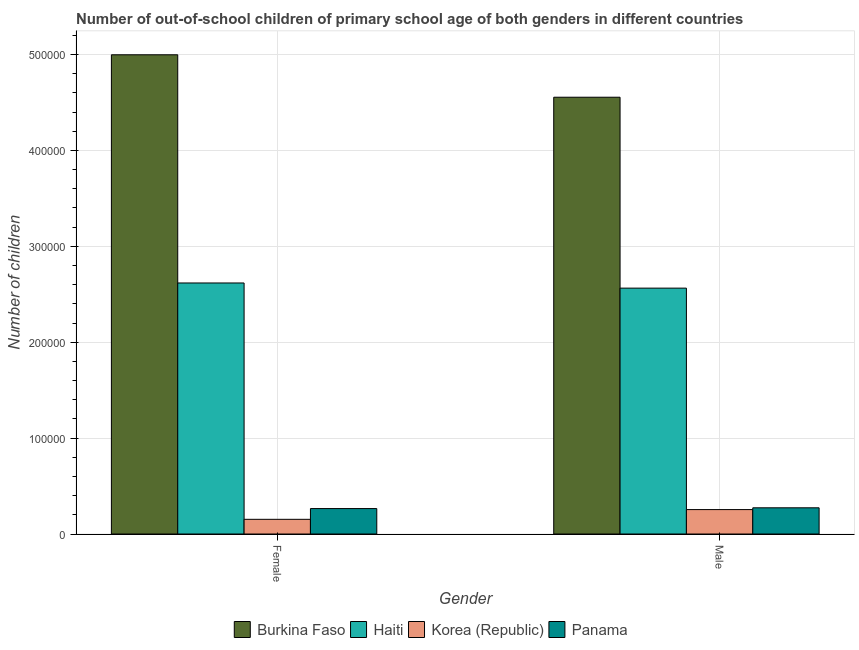How many different coloured bars are there?
Ensure brevity in your answer.  4. What is the number of female out-of-school students in Burkina Faso?
Provide a succinct answer. 5.00e+05. Across all countries, what is the maximum number of female out-of-school students?
Offer a terse response. 5.00e+05. Across all countries, what is the minimum number of female out-of-school students?
Keep it short and to the point. 1.53e+04. In which country was the number of male out-of-school students maximum?
Keep it short and to the point. Burkina Faso. In which country was the number of female out-of-school students minimum?
Give a very brief answer. Korea (Republic). What is the total number of female out-of-school students in the graph?
Your answer should be very brief. 8.03e+05. What is the difference between the number of male out-of-school students in Haiti and that in Korea (Republic)?
Your answer should be very brief. 2.31e+05. What is the difference between the number of male out-of-school students in Burkina Faso and the number of female out-of-school students in Panama?
Provide a short and direct response. 4.29e+05. What is the average number of male out-of-school students per country?
Your answer should be compact. 1.91e+05. What is the difference between the number of male out-of-school students and number of female out-of-school students in Panama?
Give a very brief answer. 795. In how many countries, is the number of female out-of-school students greater than 360000 ?
Provide a short and direct response. 1. What is the ratio of the number of male out-of-school students in Haiti to that in Korea (Republic)?
Your response must be concise. 10.07. Is the number of female out-of-school students in Panama less than that in Korea (Republic)?
Your answer should be very brief. No. What does the 2nd bar from the left in Male represents?
Keep it short and to the point. Haiti. What does the 1st bar from the right in Male represents?
Ensure brevity in your answer.  Panama. How many bars are there?
Your response must be concise. 8. Are all the bars in the graph horizontal?
Ensure brevity in your answer.  No. What is the difference between two consecutive major ticks on the Y-axis?
Provide a short and direct response. 1.00e+05. How many legend labels are there?
Make the answer very short. 4. How are the legend labels stacked?
Make the answer very short. Horizontal. What is the title of the graph?
Your answer should be very brief. Number of out-of-school children of primary school age of both genders in different countries. Does "West Bank and Gaza" appear as one of the legend labels in the graph?
Offer a terse response. No. What is the label or title of the Y-axis?
Provide a succinct answer. Number of children. What is the Number of children of Burkina Faso in Female?
Your response must be concise. 5.00e+05. What is the Number of children in Haiti in Female?
Give a very brief answer. 2.62e+05. What is the Number of children in Korea (Republic) in Female?
Your answer should be compact. 1.53e+04. What is the Number of children in Panama in Female?
Offer a very short reply. 2.65e+04. What is the Number of children of Burkina Faso in Male?
Keep it short and to the point. 4.55e+05. What is the Number of children in Haiti in Male?
Keep it short and to the point. 2.56e+05. What is the Number of children of Korea (Republic) in Male?
Your answer should be very brief. 2.55e+04. What is the Number of children of Panama in Male?
Give a very brief answer. 2.73e+04. Across all Gender, what is the maximum Number of children of Burkina Faso?
Your response must be concise. 5.00e+05. Across all Gender, what is the maximum Number of children of Haiti?
Provide a succinct answer. 2.62e+05. Across all Gender, what is the maximum Number of children in Korea (Republic)?
Provide a succinct answer. 2.55e+04. Across all Gender, what is the maximum Number of children in Panama?
Make the answer very short. 2.73e+04. Across all Gender, what is the minimum Number of children in Burkina Faso?
Provide a succinct answer. 4.55e+05. Across all Gender, what is the minimum Number of children of Haiti?
Provide a short and direct response. 2.56e+05. Across all Gender, what is the minimum Number of children in Korea (Republic)?
Keep it short and to the point. 1.53e+04. Across all Gender, what is the minimum Number of children of Panama?
Offer a terse response. 2.65e+04. What is the total Number of children of Burkina Faso in the graph?
Your answer should be compact. 9.55e+05. What is the total Number of children of Haiti in the graph?
Your answer should be very brief. 5.18e+05. What is the total Number of children in Korea (Republic) in the graph?
Offer a very short reply. 4.08e+04. What is the total Number of children of Panama in the graph?
Your answer should be compact. 5.38e+04. What is the difference between the Number of children in Burkina Faso in Female and that in Male?
Offer a terse response. 4.43e+04. What is the difference between the Number of children of Haiti in Female and that in Male?
Your answer should be very brief. 5382. What is the difference between the Number of children in Korea (Republic) in Female and that in Male?
Keep it short and to the point. -1.02e+04. What is the difference between the Number of children in Panama in Female and that in Male?
Ensure brevity in your answer.  -795. What is the difference between the Number of children of Burkina Faso in Female and the Number of children of Haiti in Male?
Your answer should be very brief. 2.43e+05. What is the difference between the Number of children in Burkina Faso in Female and the Number of children in Korea (Republic) in Male?
Your answer should be very brief. 4.74e+05. What is the difference between the Number of children of Burkina Faso in Female and the Number of children of Panama in Male?
Your answer should be compact. 4.72e+05. What is the difference between the Number of children of Haiti in Female and the Number of children of Korea (Republic) in Male?
Ensure brevity in your answer.  2.36e+05. What is the difference between the Number of children of Haiti in Female and the Number of children of Panama in Male?
Make the answer very short. 2.34e+05. What is the difference between the Number of children of Korea (Republic) in Female and the Number of children of Panama in Male?
Keep it short and to the point. -1.20e+04. What is the average Number of children in Burkina Faso per Gender?
Your response must be concise. 4.78e+05. What is the average Number of children in Haiti per Gender?
Give a very brief answer. 2.59e+05. What is the average Number of children in Korea (Republic) per Gender?
Your response must be concise. 2.04e+04. What is the average Number of children in Panama per Gender?
Keep it short and to the point. 2.69e+04. What is the difference between the Number of children in Burkina Faso and Number of children in Haiti in Female?
Give a very brief answer. 2.38e+05. What is the difference between the Number of children in Burkina Faso and Number of children in Korea (Republic) in Female?
Your answer should be compact. 4.84e+05. What is the difference between the Number of children of Burkina Faso and Number of children of Panama in Female?
Ensure brevity in your answer.  4.73e+05. What is the difference between the Number of children of Haiti and Number of children of Korea (Republic) in Female?
Provide a short and direct response. 2.46e+05. What is the difference between the Number of children of Haiti and Number of children of Panama in Female?
Provide a succinct answer. 2.35e+05. What is the difference between the Number of children of Korea (Republic) and Number of children of Panama in Female?
Provide a short and direct response. -1.12e+04. What is the difference between the Number of children in Burkina Faso and Number of children in Haiti in Male?
Your answer should be very brief. 1.99e+05. What is the difference between the Number of children in Burkina Faso and Number of children in Korea (Republic) in Male?
Make the answer very short. 4.30e+05. What is the difference between the Number of children in Burkina Faso and Number of children in Panama in Male?
Ensure brevity in your answer.  4.28e+05. What is the difference between the Number of children of Haiti and Number of children of Korea (Republic) in Male?
Your response must be concise. 2.31e+05. What is the difference between the Number of children in Haiti and Number of children in Panama in Male?
Provide a short and direct response. 2.29e+05. What is the difference between the Number of children of Korea (Republic) and Number of children of Panama in Male?
Provide a short and direct response. -1846. What is the ratio of the Number of children of Burkina Faso in Female to that in Male?
Provide a short and direct response. 1.1. What is the ratio of the Number of children of Korea (Republic) in Female to that in Male?
Keep it short and to the point. 0.6. What is the ratio of the Number of children in Panama in Female to that in Male?
Keep it short and to the point. 0.97. What is the difference between the highest and the second highest Number of children of Burkina Faso?
Give a very brief answer. 4.43e+04. What is the difference between the highest and the second highest Number of children of Haiti?
Your answer should be compact. 5382. What is the difference between the highest and the second highest Number of children of Korea (Republic)?
Your response must be concise. 1.02e+04. What is the difference between the highest and the second highest Number of children in Panama?
Ensure brevity in your answer.  795. What is the difference between the highest and the lowest Number of children in Burkina Faso?
Keep it short and to the point. 4.43e+04. What is the difference between the highest and the lowest Number of children of Haiti?
Ensure brevity in your answer.  5382. What is the difference between the highest and the lowest Number of children in Korea (Republic)?
Offer a very short reply. 1.02e+04. What is the difference between the highest and the lowest Number of children of Panama?
Your response must be concise. 795. 